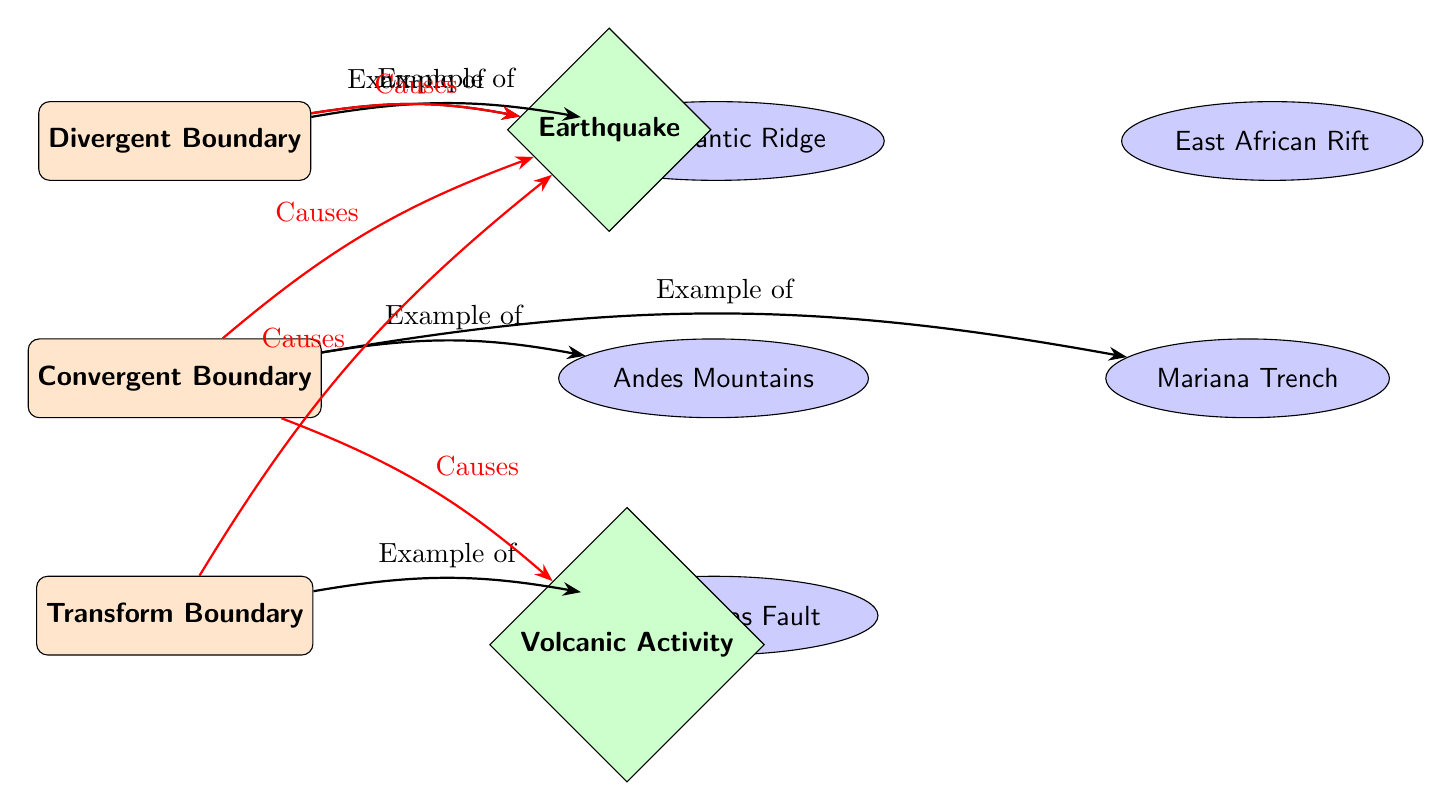What are the three types of boundaries shown in the diagram? The diagram explicitly labels three types of boundaries: Divergent Boundary, Convergent Boundary, and Transform Boundary.
Answer: Divergent Boundary, Convergent Boundary, Transform Boundary How many examples are given under the Convergent Boundary? Under the Convergent Boundary, there are two examples listed: Andes Mountains and Mariana Trench. Therefore, the count is two.
Answer: 2 What causes Earthquakes according to the diagram? The diagram indicates that Earthquakes are caused by Divergent Boundary, Convergent Boundary, and Transform Boundary, involving red arrows pointing from the boundaries to the Earthquake node.
Answer: Divergent Boundary, Convergent Boundary, Transform Boundary Which boundary is associated with San Andreas Fault? The San Andreas Fault is connected with the Transform Boundary as shown in the diagram, where a directed arrow indicates the example linked to this boundary type.
Answer: Transform Boundary What type of volcanic activity is linked with Convergent Boundary? The diagram directly connects Volcanic Activity to the Convergent Boundary through a red arrow indicating a cause-effect relationship.
Answer: Volcanic Activity How many examples are listed for Divergent Boundary? There are two examples provided under the Divergent Boundary: Mid-Atlantic Ridge and East African Rift, making the total two examples.
Answer: 2 Which two effects are indicated from the Convergent Boundary? The diagram indicates that the Convergent Boundary leads to two effects: Earthquake and Volcanic Activity, shown by direct arrows leading to the respective effect nodes.
Answer: Earthquake, Volcanic Activity What is the relationship between Divergent Boundary and Earthquake? According to the diagram, there is a direct cause indicated by a red arrow showing that Divergent Boundary causes Earthquakes, demonstrating a clear relationship between them.
Answer: Causes Earthquake 